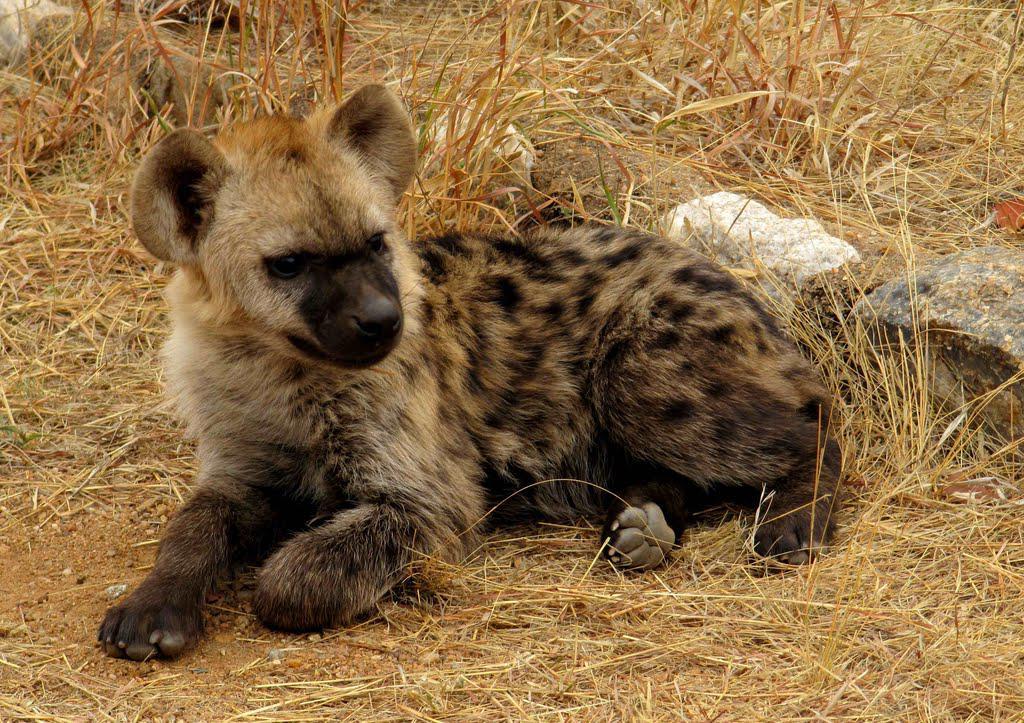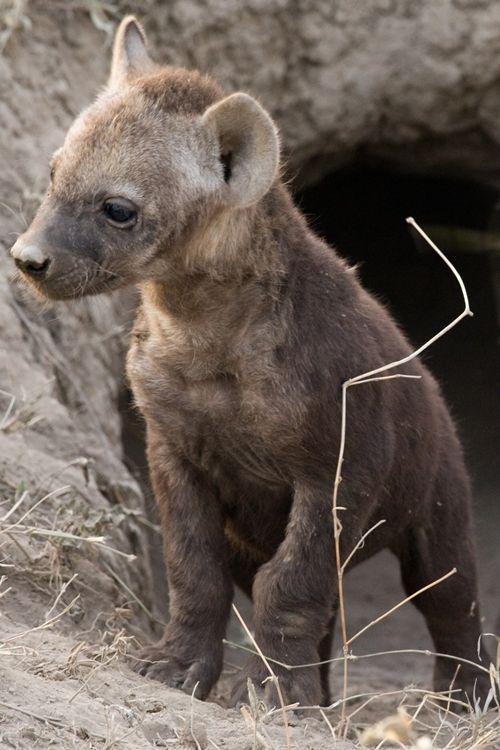The first image is the image on the left, the second image is the image on the right. Analyze the images presented: Is the assertion "The combined images contain a total of four hyenas, including at least one hyena pup posed with its parent." valid? Answer yes or no. No. The first image is the image on the left, the second image is the image on the right. Considering the images on both sides, is "A single animal stands in one of the images, while an animal lies on the ground in the other." valid? Answer yes or no. Yes. 